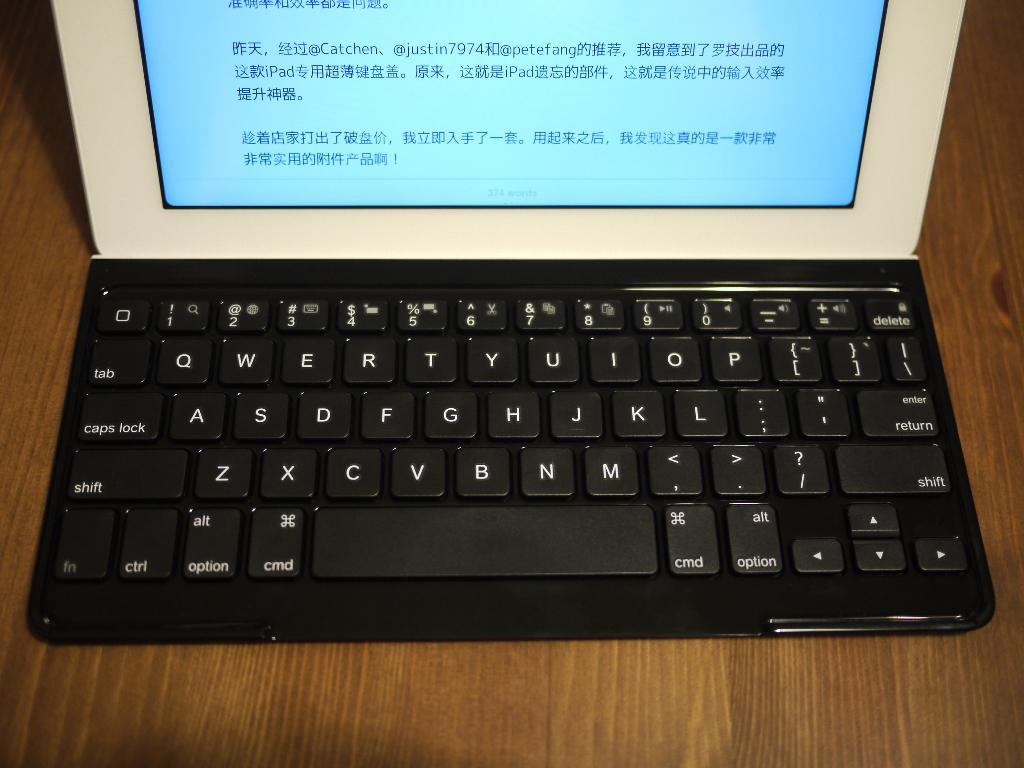<image>
Give a short and clear explanation of the subsequent image. The laptop screen shows a text that is mainly in a language other than English. 